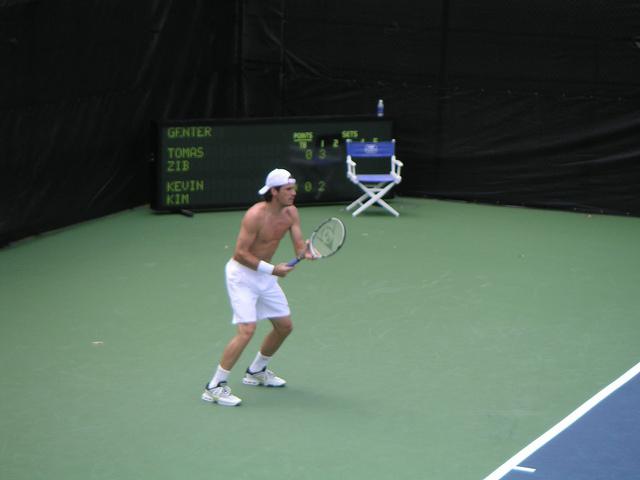Is there an umpire?
Give a very brief answer. No. What color is the guy's shirt?
Quick response, please. No shirt. What sport is being played?
Short answer required. Tennis. What is on the court to the right of the player?
Answer briefly. Chair. 